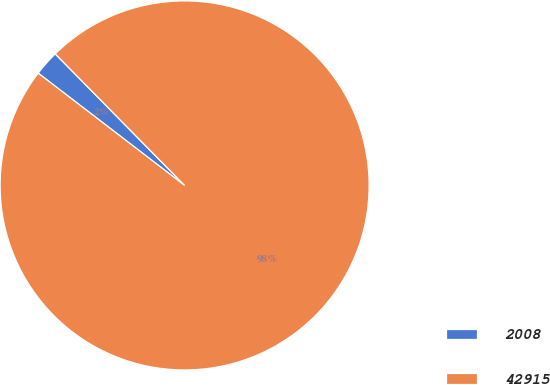Convert chart to OTSL. <chart><loc_0><loc_0><loc_500><loc_500><pie_chart><fcel>2008<fcel>42915<nl><fcel>2.22%<fcel>97.78%<nl></chart> 